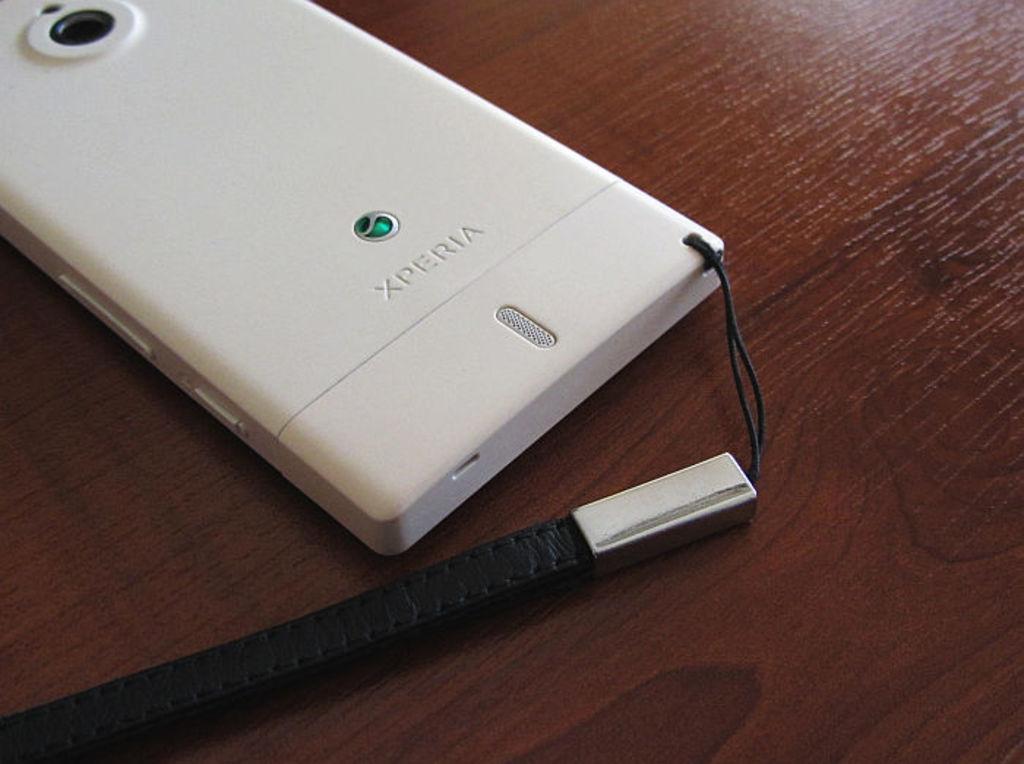What kind of phone is this?
Provide a succinct answer. Xperia. 